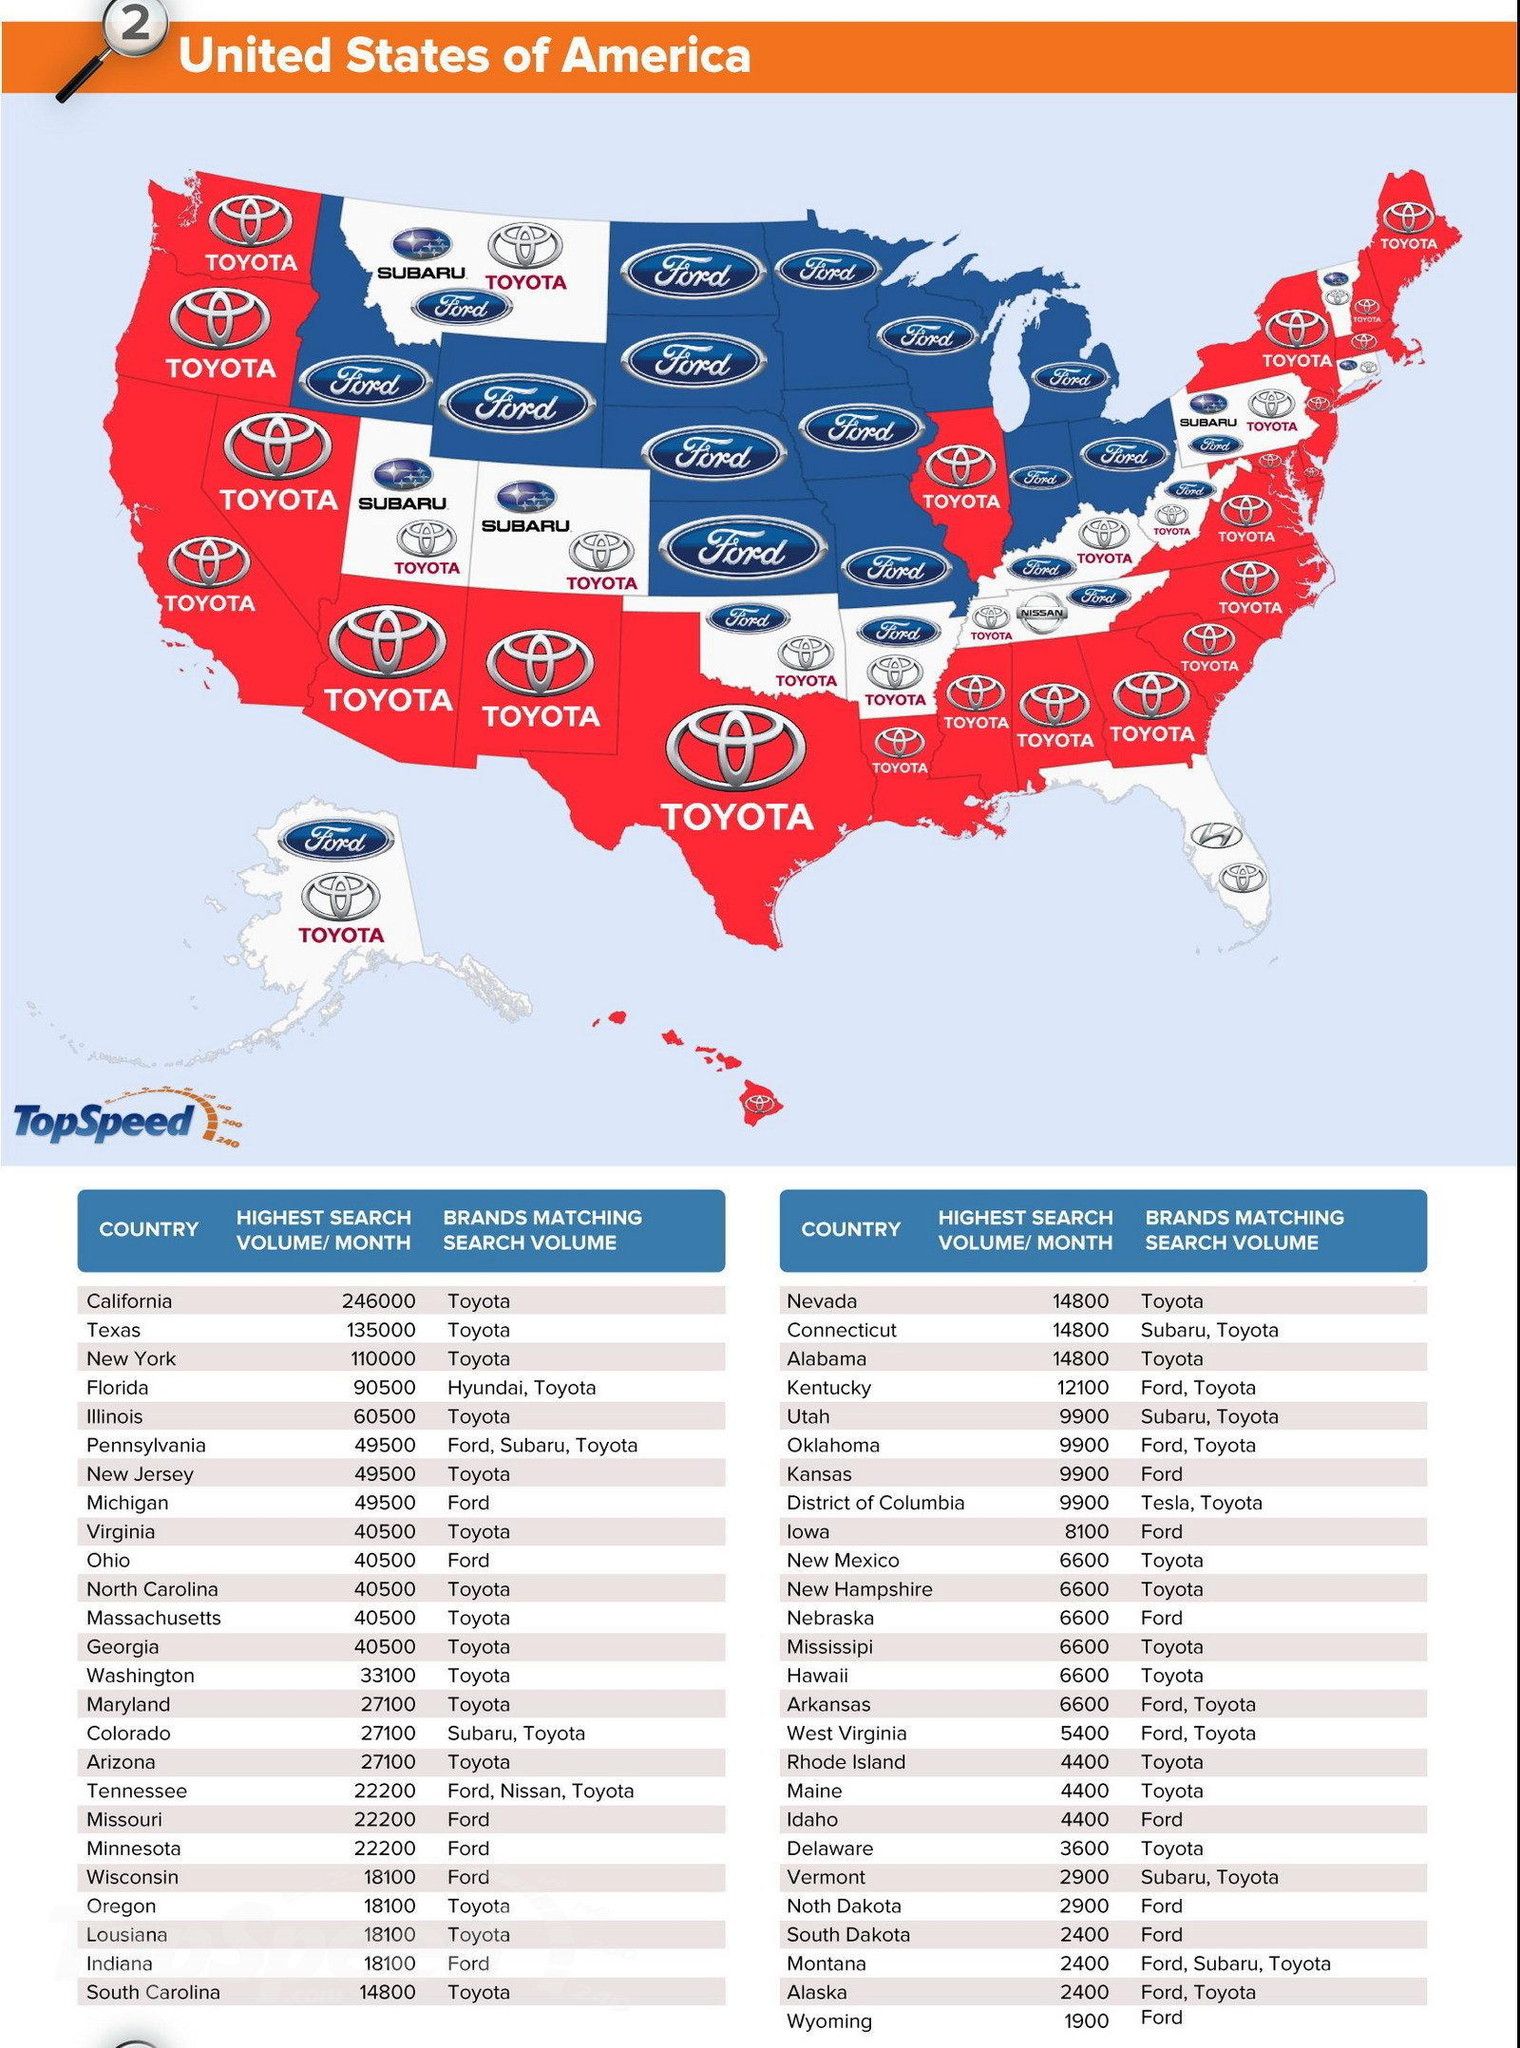Indicate a few pertinent items in this graphic. There are 51 countries listed in the table. The highest search volume listed on the second column and second row is 135,000. The difference in the highest search volumes between California and Texas is 111,000. The highest monthly search volume in South Dakota, Montana, and Alaska is 2,400. There are a total of 7 states in the United States that are shared by both Ford and Toyota, and these states are the only ones in which both companies have a significant presence. 